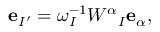<formula> <loc_0><loc_0><loc_500><loc_500>{ e } _ { I ^ { \prime } } = \omega _ { I } ^ { - 1 } W ^ { \alpha _ { I } { e } _ { \alpha } ,</formula> 